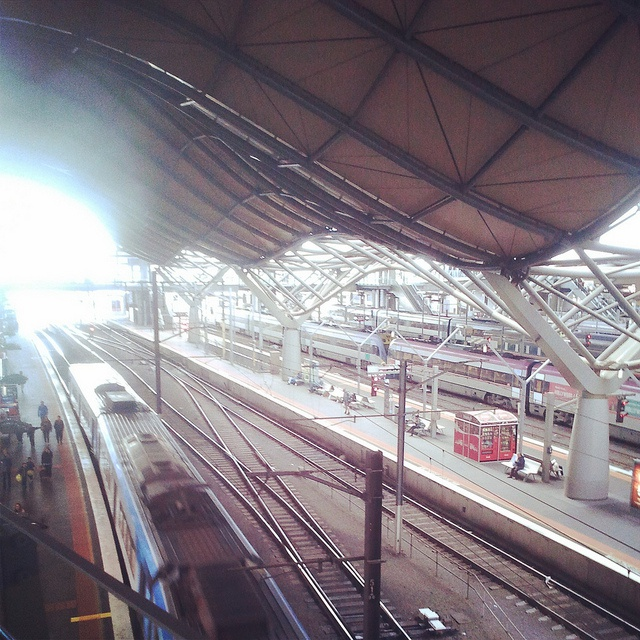Describe the objects in this image and their specific colors. I can see train in purple, darkgray, and black tones, train in purple, darkgray, lightgray, and gray tones, train in purple, lightgray, and darkgray tones, bench in purple, white, darkgray, and gray tones, and people in purple, gray, and black tones in this image. 